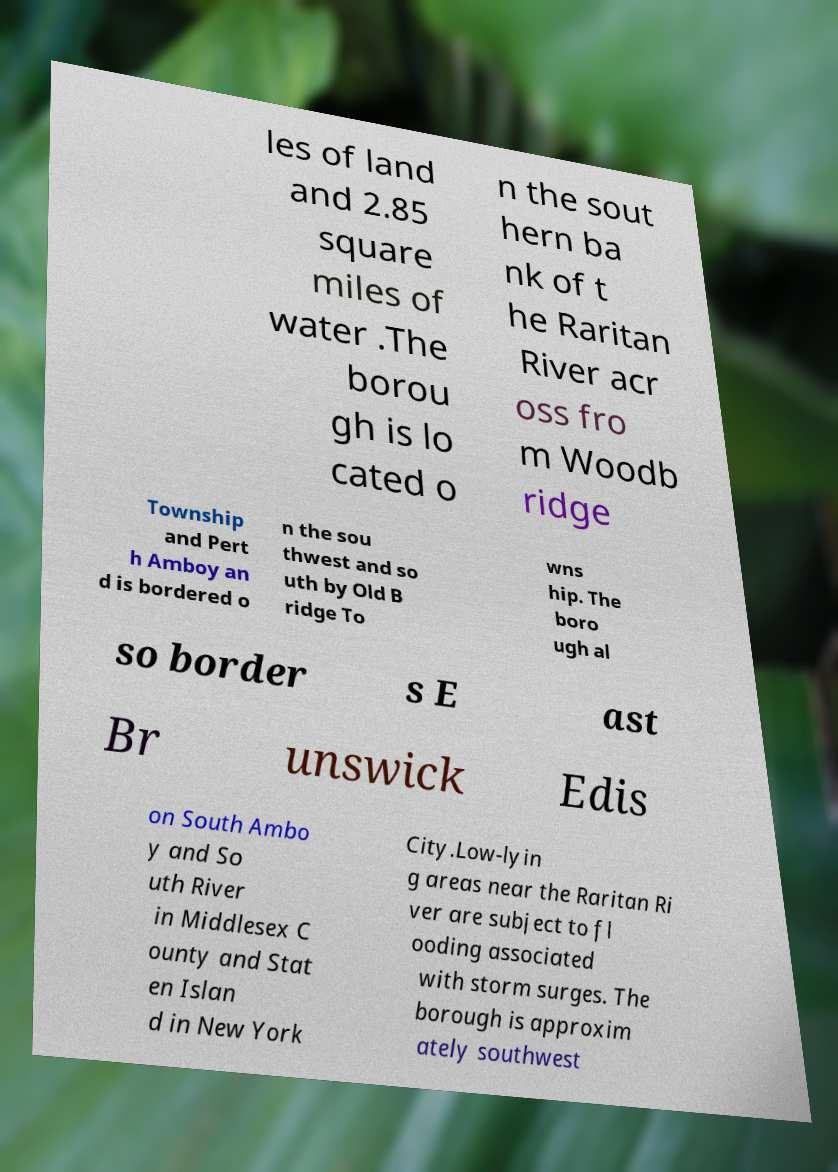Can you read and provide the text displayed in the image?This photo seems to have some interesting text. Can you extract and type it out for me? les of land and 2.85 square miles of water .The borou gh is lo cated o n the sout hern ba nk of t he Raritan River acr oss fro m Woodb ridge Township and Pert h Amboy an d is bordered o n the sou thwest and so uth by Old B ridge To wns hip. The boro ugh al so border s E ast Br unswick Edis on South Ambo y and So uth River in Middlesex C ounty and Stat en Islan d in New York City.Low-lyin g areas near the Raritan Ri ver are subject to fl ooding associated with storm surges. The borough is approxim ately southwest 